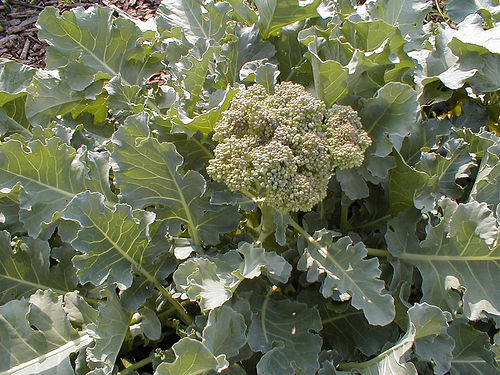What type of plants are these? The plant in the image is broccoli, specifically shown in its growing stage before the individual florets are cut for consumption. This image includes both the green florets and the surrounding leaves, which are characteristic of mature broccoli plants. 